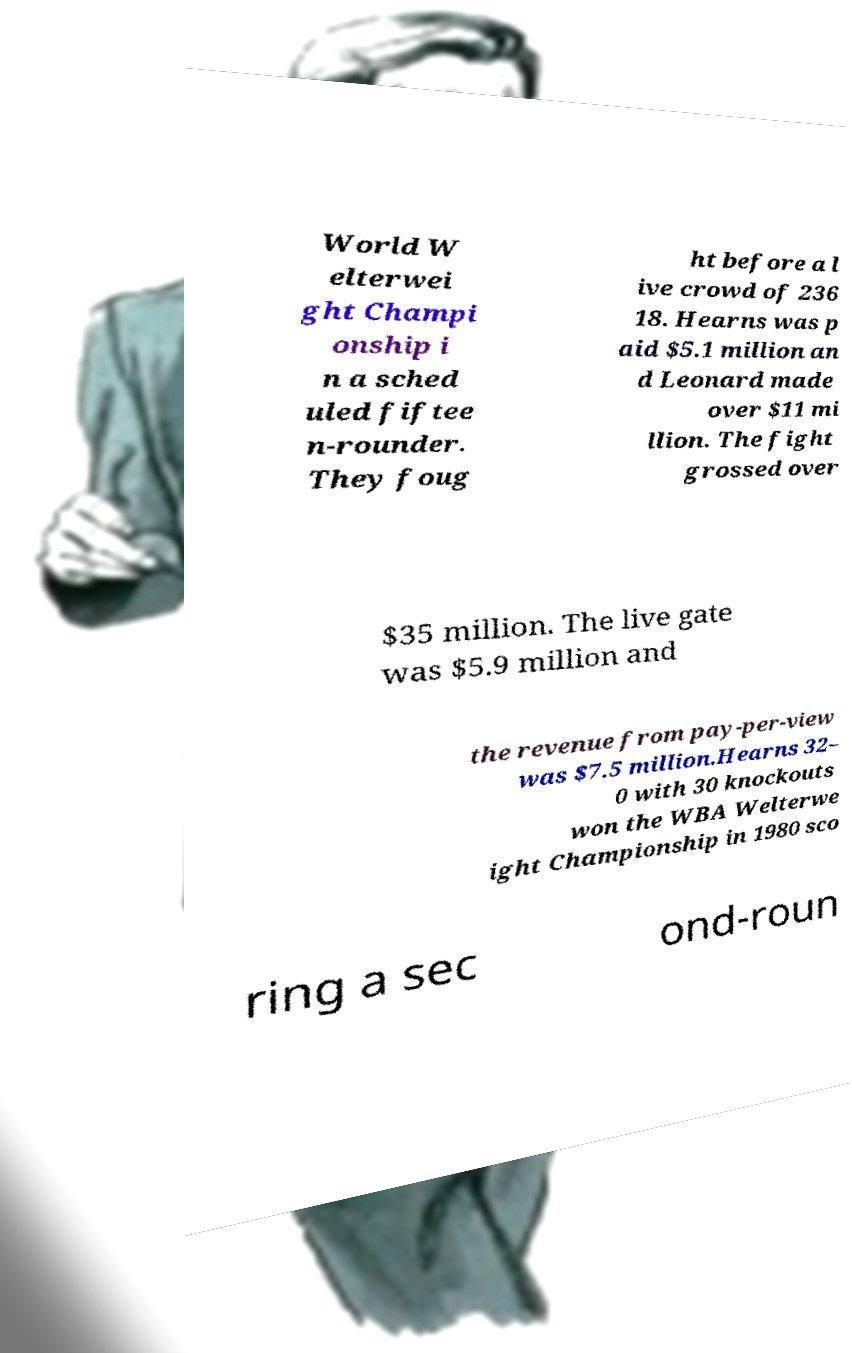Can you read and provide the text displayed in the image?This photo seems to have some interesting text. Can you extract and type it out for me? World W elterwei ght Champi onship i n a sched uled fiftee n-rounder. They foug ht before a l ive crowd of 236 18. Hearns was p aid $5.1 million an d Leonard made over $11 mi llion. The fight grossed over $35 million. The live gate was $5.9 million and the revenue from pay-per-view was $7.5 million.Hearns 32– 0 with 30 knockouts won the WBA Welterwe ight Championship in 1980 sco ring a sec ond-roun 